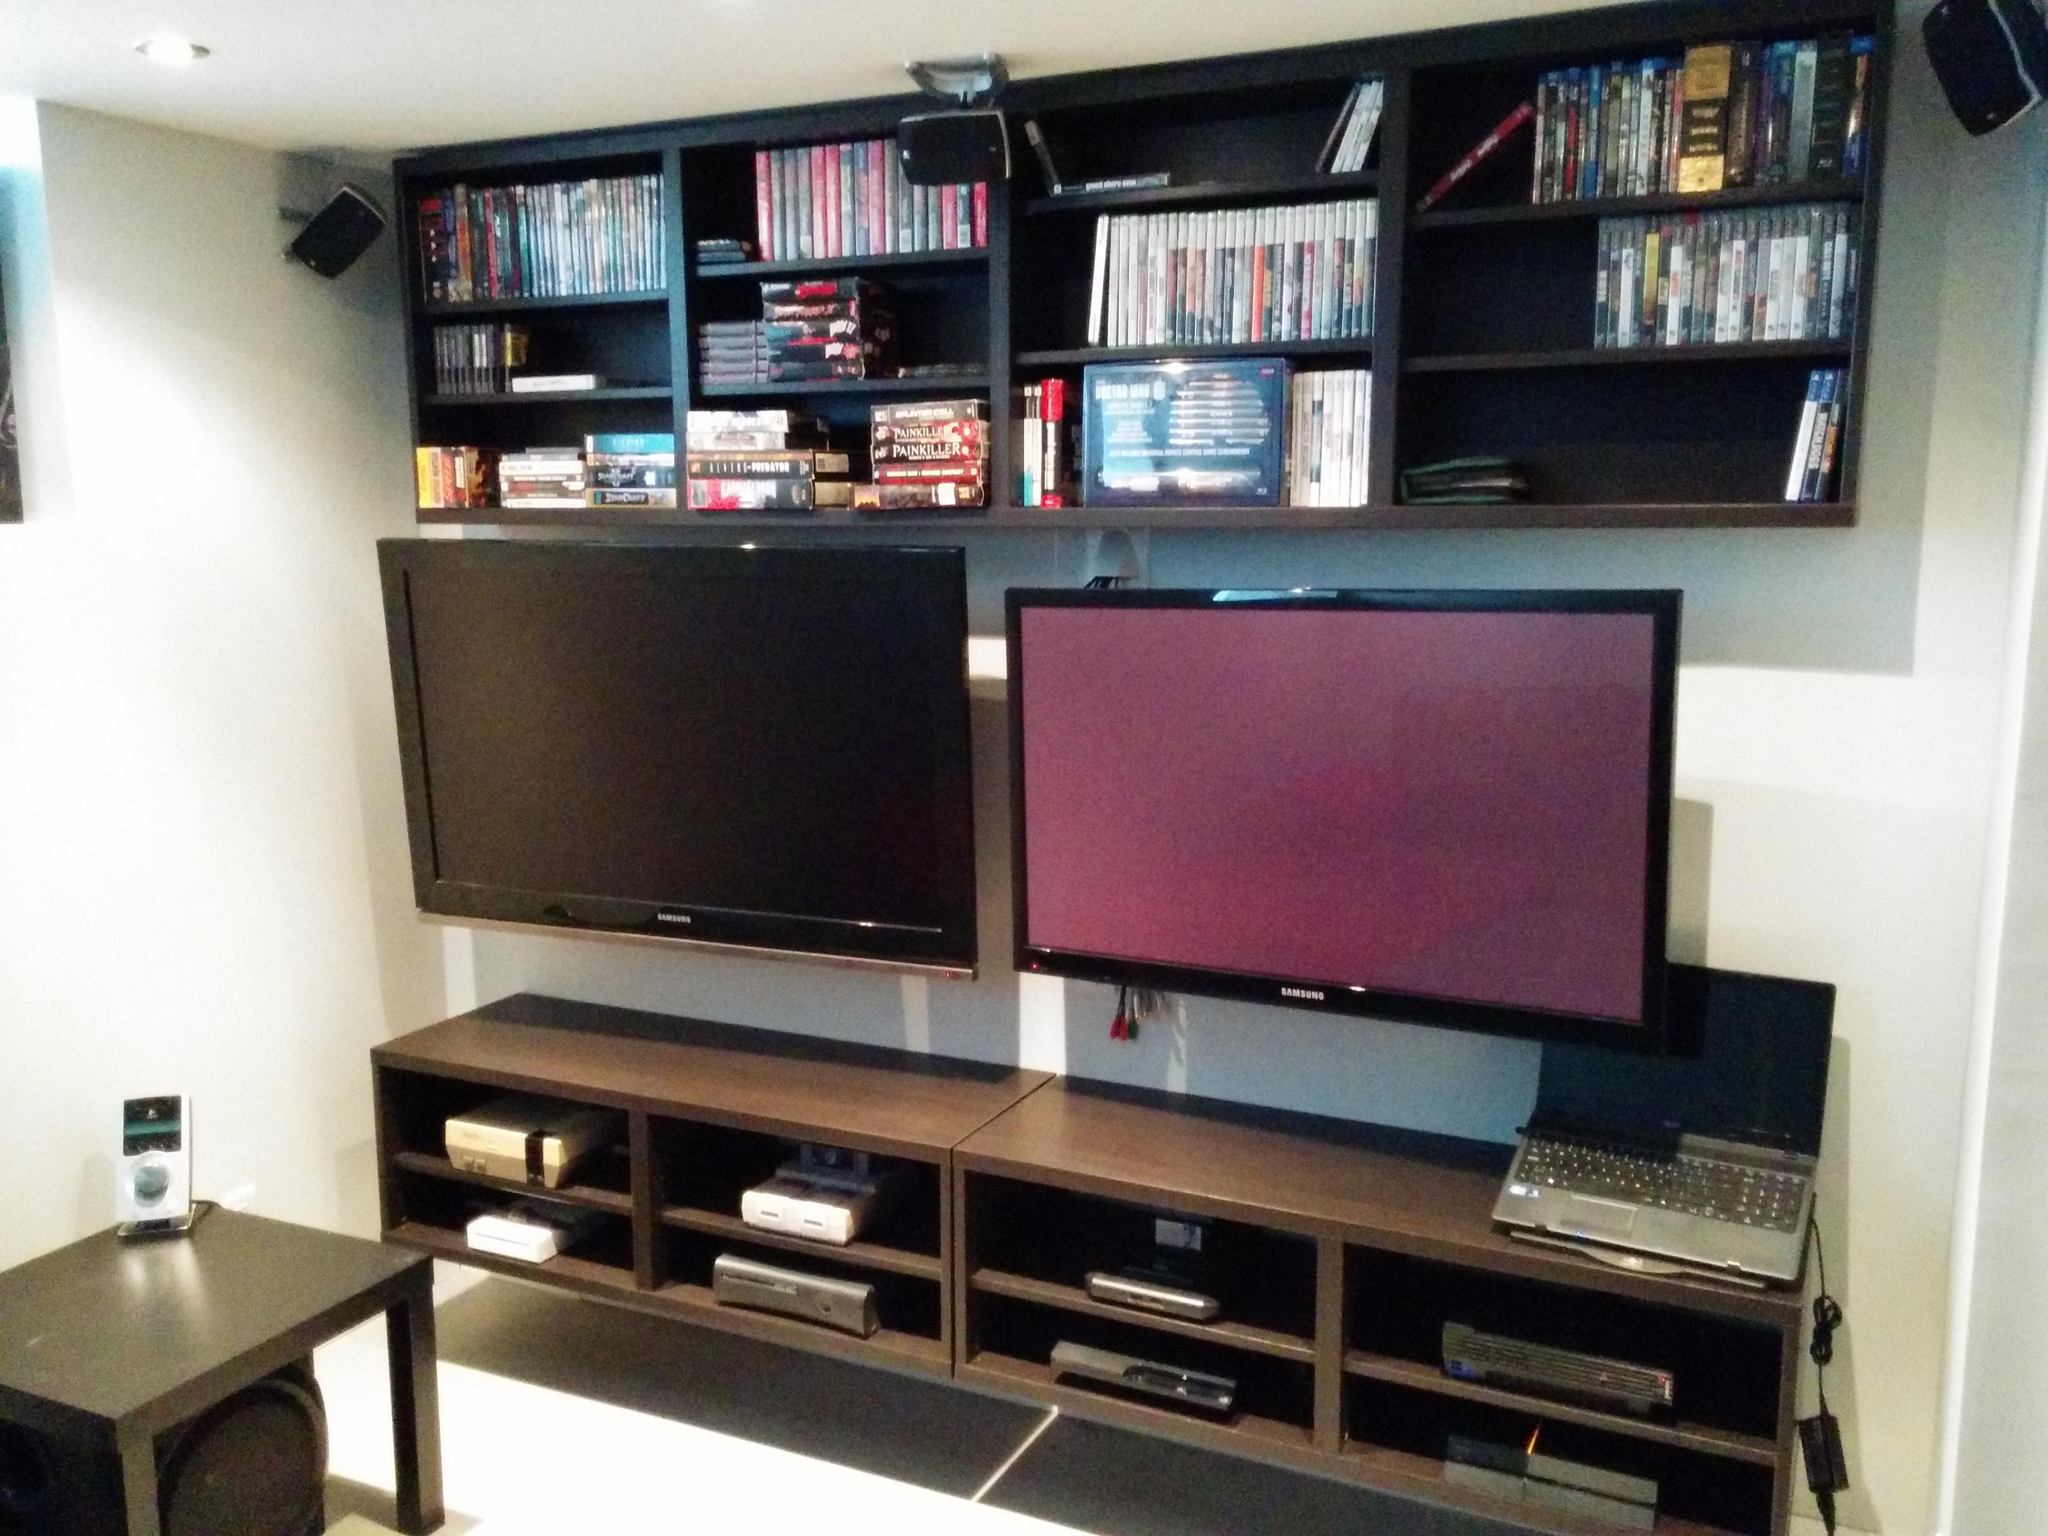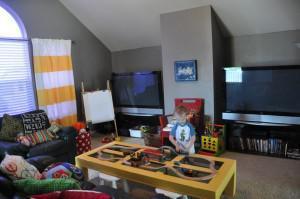The first image is the image on the left, the second image is the image on the right. Examine the images to the left and right. Is the description "There are no more than 4 standalone monitors." accurate? Answer yes or no. Yes. 